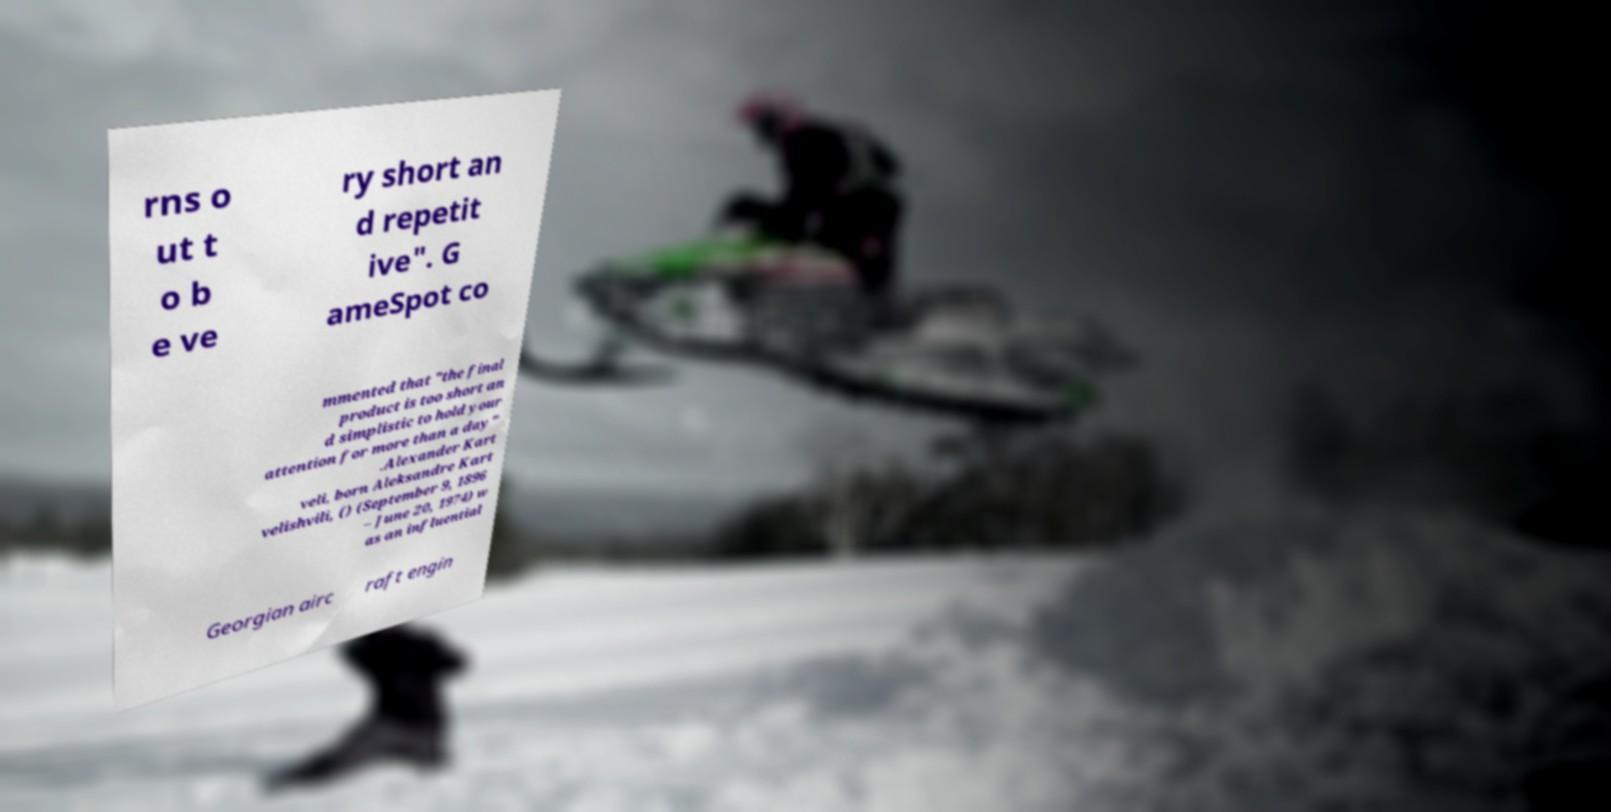For documentation purposes, I need the text within this image transcribed. Could you provide that? rns o ut t o b e ve ry short an d repetit ive". G ameSpot co mmented that "the final product is too short an d simplistic to hold your attention for more than a day" .Alexander Kart veli, born Aleksandre Kart velishvili, () (September 9, 1896 – June 20, 1974) w as an influential Georgian airc raft engin 